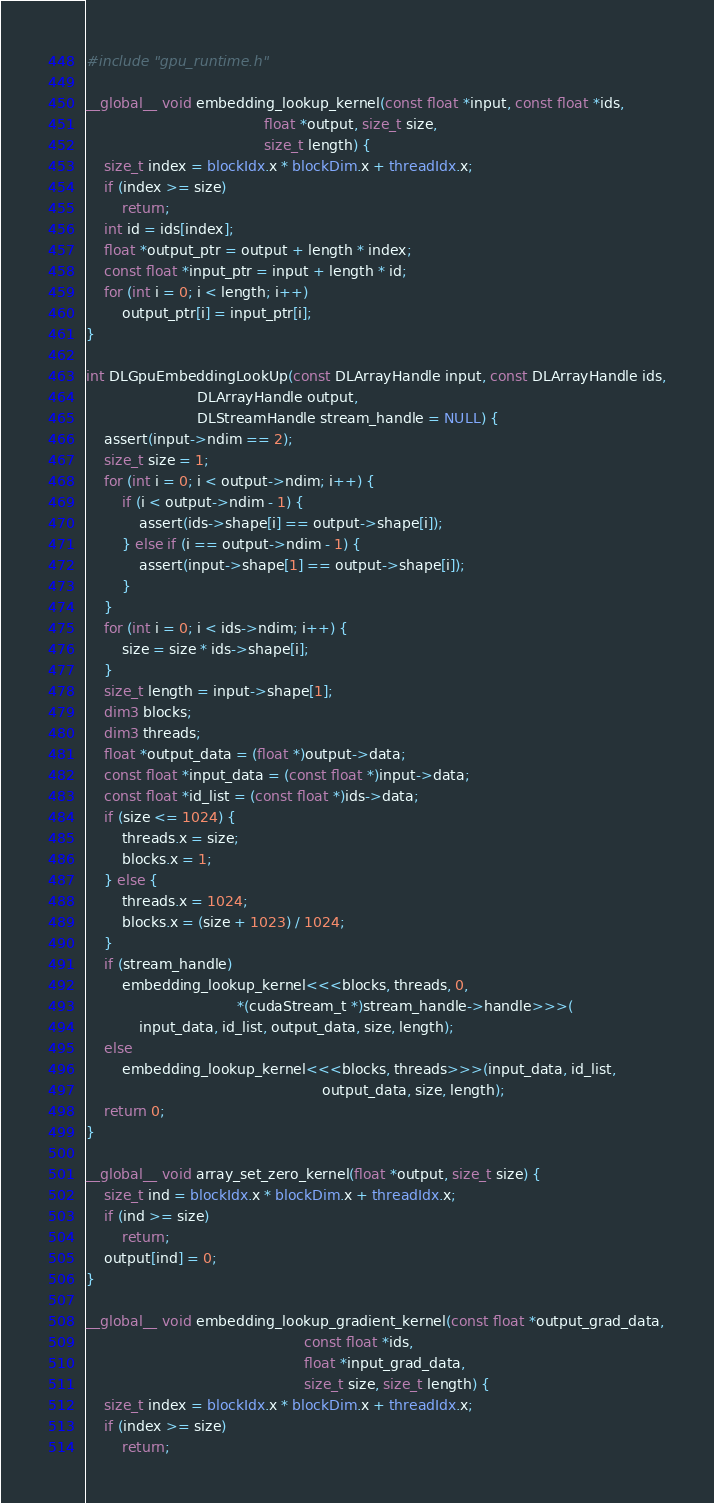<code> <loc_0><loc_0><loc_500><loc_500><_Cuda_>#include "gpu_runtime.h"

__global__ void embedding_lookup_kernel(const float *input, const float *ids,
                                        float *output, size_t size,
                                        size_t length) {
    size_t index = blockIdx.x * blockDim.x + threadIdx.x;
    if (index >= size)
        return;
    int id = ids[index];
    float *output_ptr = output + length * index;
    const float *input_ptr = input + length * id;
    for (int i = 0; i < length; i++)
        output_ptr[i] = input_ptr[i];
}

int DLGpuEmbeddingLookUp(const DLArrayHandle input, const DLArrayHandle ids,
                         DLArrayHandle output,
                         DLStreamHandle stream_handle = NULL) {
    assert(input->ndim == 2);
    size_t size = 1;
    for (int i = 0; i < output->ndim; i++) {
        if (i < output->ndim - 1) {
            assert(ids->shape[i] == output->shape[i]);
        } else if (i == output->ndim - 1) {
            assert(input->shape[1] == output->shape[i]);
        }
    }
    for (int i = 0; i < ids->ndim; i++) {
        size = size * ids->shape[i];
    }
    size_t length = input->shape[1];
    dim3 blocks;
    dim3 threads;
    float *output_data = (float *)output->data;
    const float *input_data = (const float *)input->data;
    const float *id_list = (const float *)ids->data;
    if (size <= 1024) {
        threads.x = size;
        blocks.x = 1;
    } else {
        threads.x = 1024;
        blocks.x = (size + 1023) / 1024;
    }
    if (stream_handle)
        embedding_lookup_kernel<<<blocks, threads, 0,
                                  *(cudaStream_t *)stream_handle->handle>>>(
            input_data, id_list, output_data, size, length);
    else
        embedding_lookup_kernel<<<blocks, threads>>>(input_data, id_list,
                                                     output_data, size, length);
    return 0;
}

__global__ void array_set_zero_kernel(float *output, size_t size) {
    size_t ind = blockIdx.x * blockDim.x + threadIdx.x;
    if (ind >= size)
        return;
    output[ind] = 0;
}

__global__ void embedding_lookup_gradient_kernel(const float *output_grad_data,
                                                 const float *ids,
                                                 float *input_grad_data,
                                                 size_t size, size_t length) {
    size_t index = blockIdx.x * blockDim.x + threadIdx.x;
    if (index >= size)
        return;</code> 